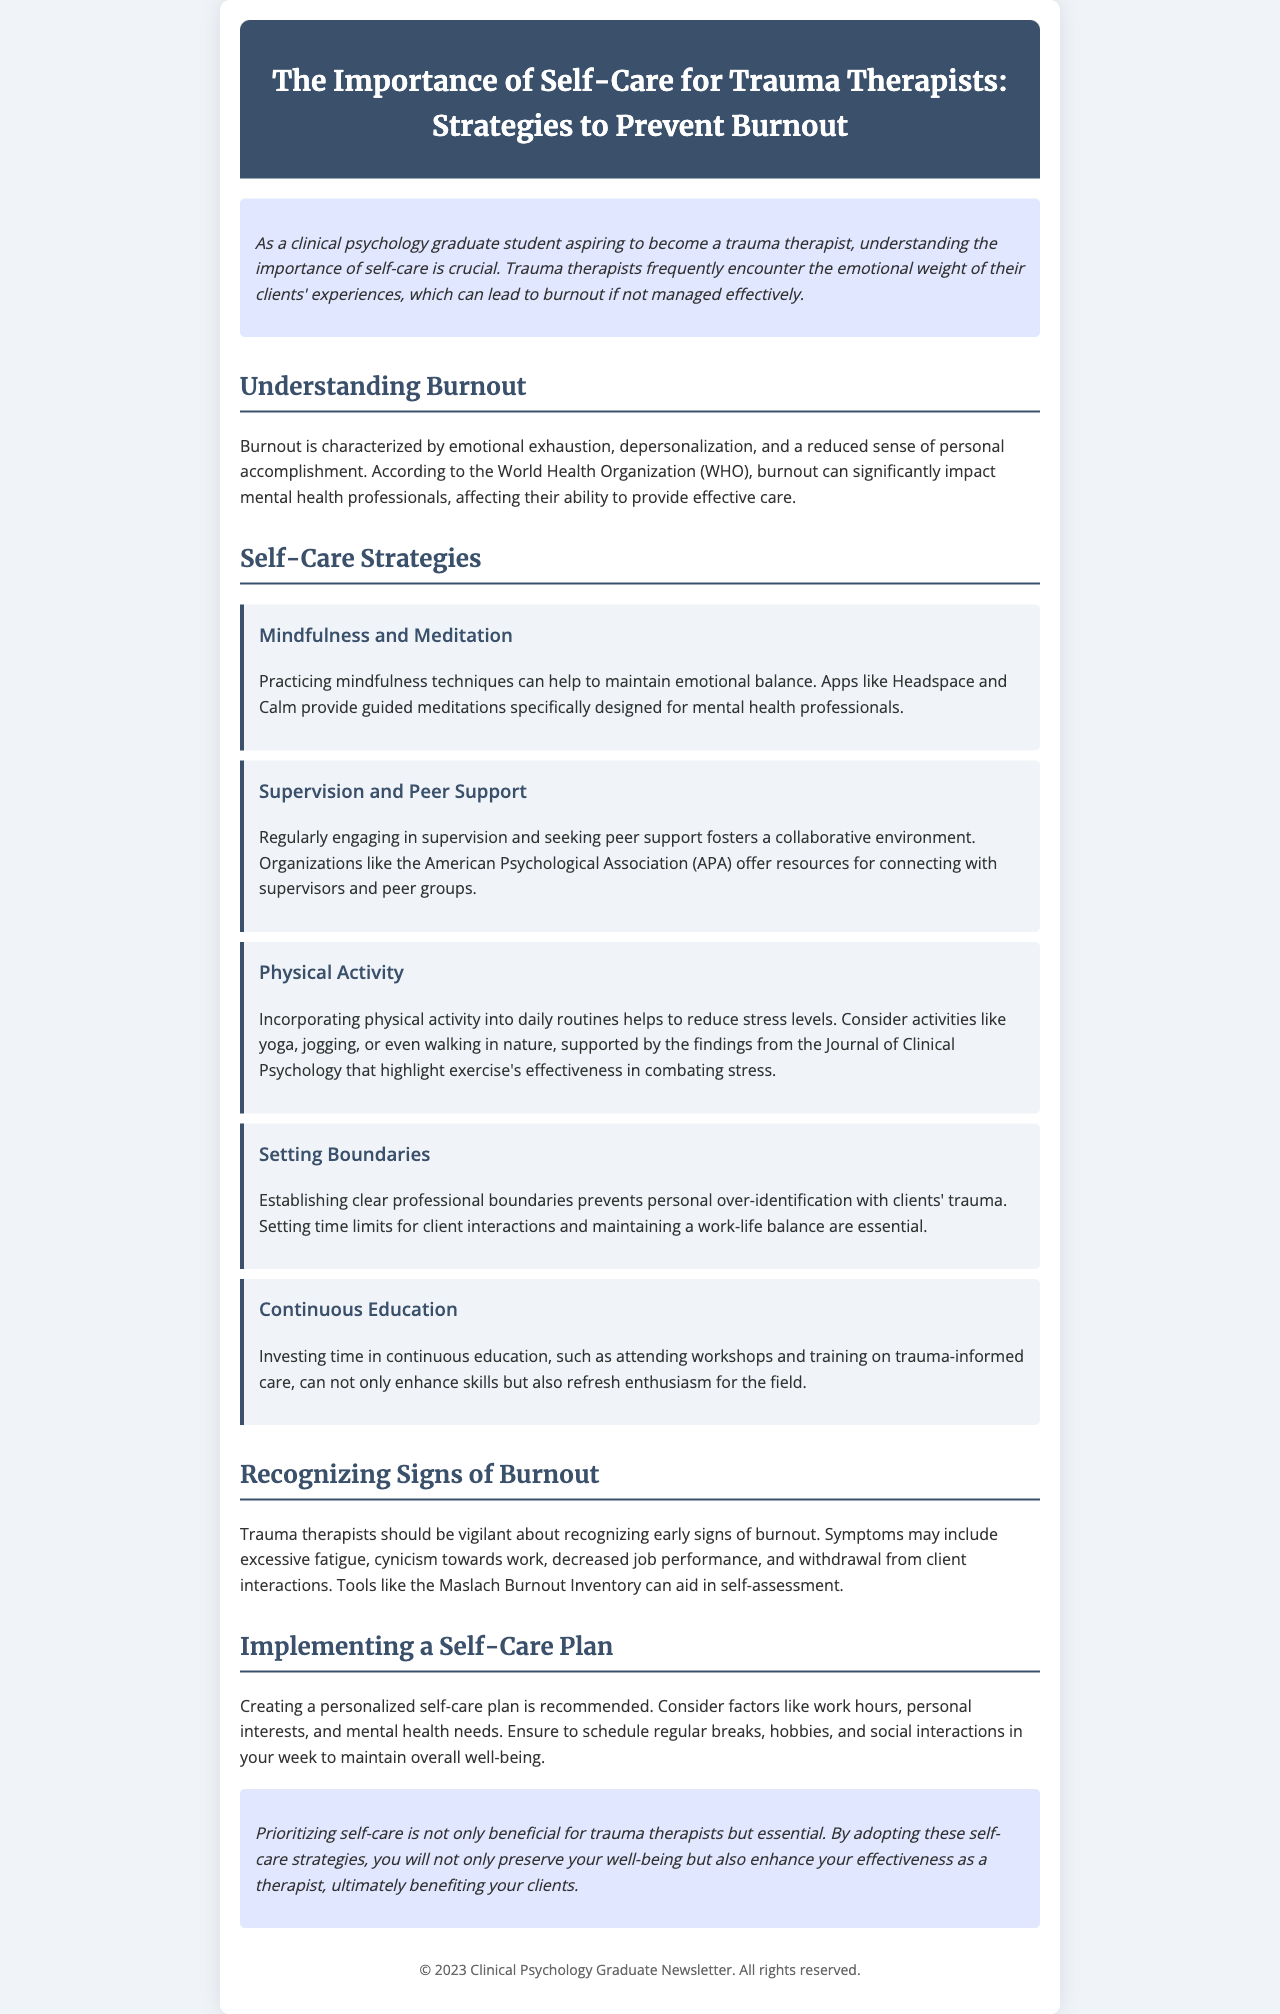What is the title of the newsletter? The title is provided in the header of the document, which is focused on self-care for trauma therapists.
Answer: The Importance of Self-Care for Trauma Therapists: Strategies to Prevent Burnout What organization offers resources for peer support? The document mentions an organization that provides resources for connecting with supervisors and peer groups, which is well-known in the psychology field.
Answer: American Psychological Association What does burnout negatively impact according to the WHO? The document states a specific effect of burnout on mental health professionals, highlighting its consequences on their professional effectiveness.
Answer: Ability to provide effective care Name a mindfulness app mentioned in the newsletter. The newsletter lists an app that helps in practicing mindfulness, particularly useful for mental health professionals.
Answer: Headspace What is one symptom of burnout? The document provides a list of symptoms associated with burnout that trauma therapists should recognize.
Answer: Excessive fatigue How often should breaks be scheduled in a self-care plan? The document advises on maintaining overall well-being by scheduling specific activities, emphasizing the need for regularity.
Answer: Regularly Which self-care strategy involves physical activity? The newsletter outlines various strategies for self-care, including one related to physical fitness that helps reduce stress.
Answer: Physical Activity What should a personalized self-care plan factor in? The document explains elements that should be included in a self-care plan for effective management of well-being.
Answer: Work hours What is the main focus of this newsletter? The intent of the newsletter is clearly stated in the introductory section, highlighting its aim for trauma therapists and their self-care.
Answer: Self-Care Strategies 